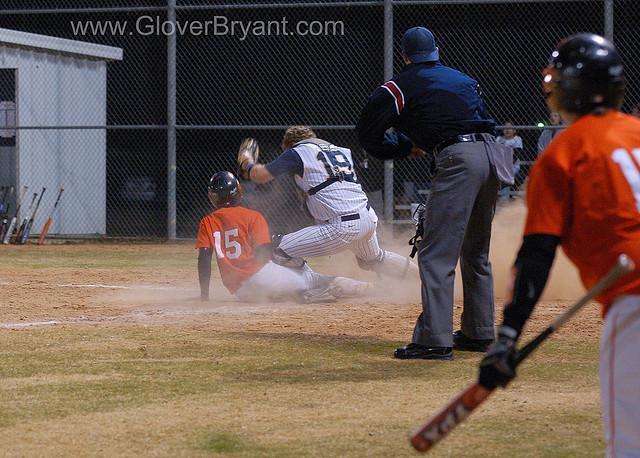How many people do you see on the field?
Give a very brief answer. 4. How many people are in the picture?
Give a very brief answer. 4. 